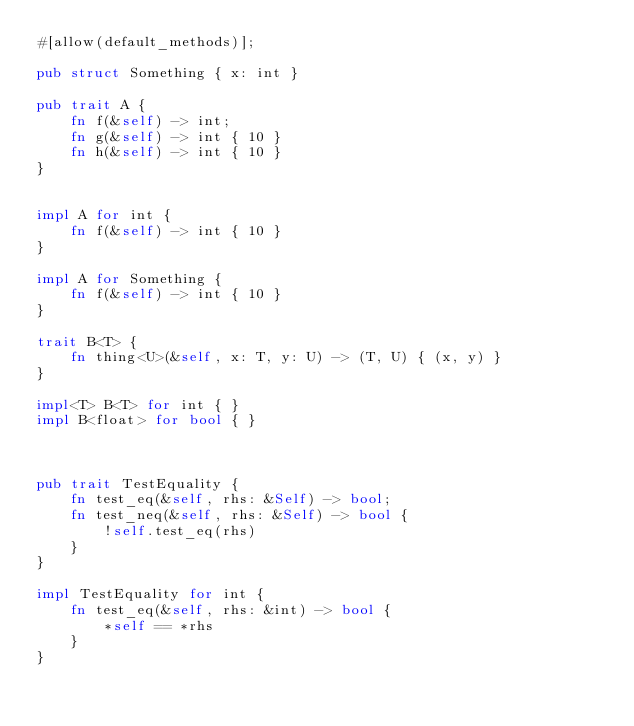<code> <loc_0><loc_0><loc_500><loc_500><_Rust_>#[allow(default_methods)];

pub struct Something { x: int }

pub trait A {
    fn f(&self) -> int;
    fn g(&self) -> int { 10 }
    fn h(&self) -> int { 10 }
}


impl A for int {
    fn f(&self) -> int { 10 }
}

impl A for Something {
    fn f(&self) -> int { 10 }
}

trait B<T> {
    fn thing<U>(&self, x: T, y: U) -> (T, U) { (x, y) }
}

impl<T> B<T> for int { }
impl B<float> for bool { }



pub trait TestEquality {
    fn test_eq(&self, rhs: &Self) -> bool;
    fn test_neq(&self, rhs: &Self) -> bool {
        !self.test_eq(rhs)
    }
}

impl TestEquality for int {
    fn test_eq(&self, rhs: &int) -> bool {
        *self == *rhs
    }
}
</code> 